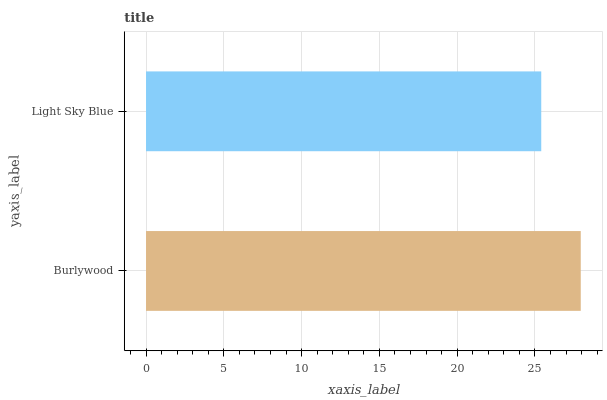Is Light Sky Blue the minimum?
Answer yes or no. Yes. Is Burlywood the maximum?
Answer yes or no. Yes. Is Light Sky Blue the maximum?
Answer yes or no. No. Is Burlywood greater than Light Sky Blue?
Answer yes or no. Yes. Is Light Sky Blue less than Burlywood?
Answer yes or no. Yes. Is Light Sky Blue greater than Burlywood?
Answer yes or no. No. Is Burlywood less than Light Sky Blue?
Answer yes or no. No. Is Burlywood the high median?
Answer yes or no. Yes. Is Light Sky Blue the low median?
Answer yes or no. Yes. Is Light Sky Blue the high median?
Answer yes or no. No. Is Burlywood the low median?
Answer yes or no. No. 